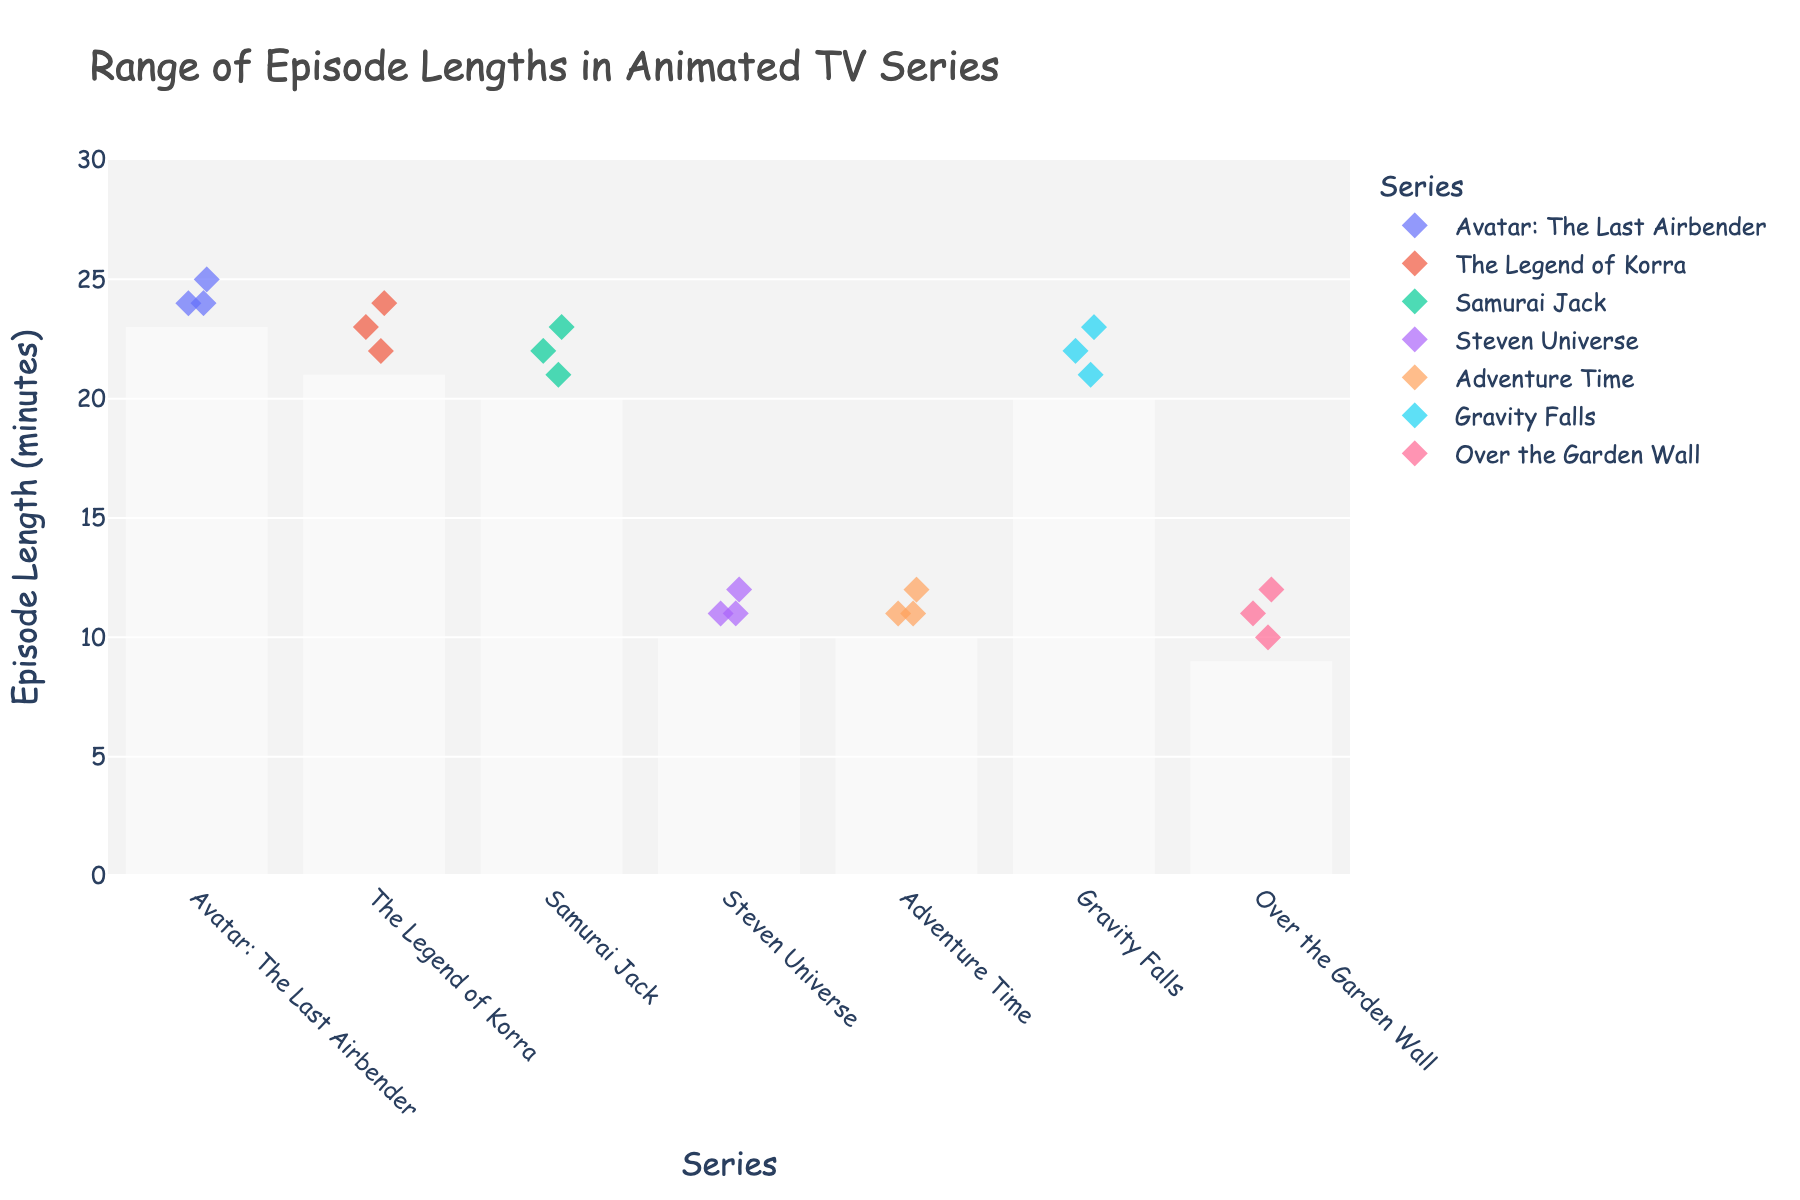What’s the title of the figure? The title is found at the top of the figure, summarizing its content.
Answer: Range of Episode Lengths in Animated TV Series Which series has the episode with the longest length? Identify the highest point on the y-axis and note the corresponding series on the x-axis.
Answer: Avatar: The Last Airbender What’s the shortest episode length for "Over the Garden Wall"? Look for the lowest value of the data points associated with "Over the Garden Wall".
Answer: 10 minutes How many episode lengths of 11 minutes are there in "Adventure Time"? Count the data points positioned at the 11-minute mark for "Adventure Time".
Answer: 2 What's the median episode length for "The Legend of Korra"? List the episode lengths for "The Legend of Korra" (22, 23, 24), order them, and find the middle value.
Answer: 23 minutes Which series has the smallest range of episode lengths? Identify the series with the smallest difference between the highest and lowest episode lengths.
Answer: Avatar: The Last Airbender (1 minute) Compare the average episode length of "Samurai Jack" and "Gravity Falls". Which is higher? Calculate the average of each series by summing the episode lengths and dividing by the number of episodes. Samurai Jack: (21+22+23)/3 = 22, Gravity Falls: (21+22+23)/3 = 22. Both averages are equal.
Answer: Equal Do any series have the same number of data points, and if so, which ones? Count the data points for each series and check for matching counts.
Answer: Several series have 3 points: Avatar: The Last Airbender, The Legend of Korra, Samurai Jack, Steven Universe, Adventure Time, Gravity Falls, Over the Garden Wall Is the range of episode lengths for "Steven Universe" wider or narrower than for "Samurai Jack"? Compare the ranges by finding the difference between the maximum and minimum episode lengths for each series. Steven Universe: 12-11=1, Samurai Jack: 23-21=2.
Answer: Narrower 